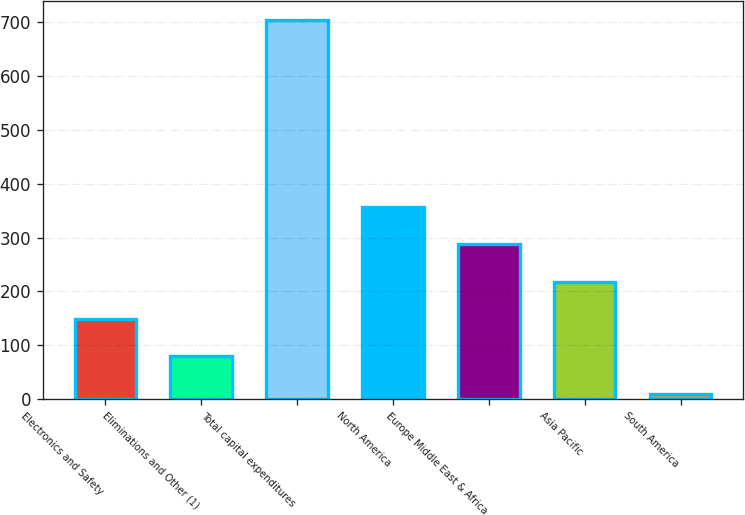<chart> <loc_0><loc_0><loc_500><loc_500><bar_chart><fcel>Electronics and Safety<fcel>Eliminations and Other (1)<fcel>Total capital expenditures<fcel>North America<fcel>Europe Middle East & Africa<fcel>Asia Pacific<fcel>South America<nl><fcel>148.8<fcel>79.4<fcel>704<fcel>357<fcel>287.6<fcel>218.2<fcel>10<nl></chart> 